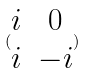<formula> <loc_0><loc_0><loc_500><loc_500>( \begin{matrix} i & 0 \\ i & - i \end{matrix} )</formula> 